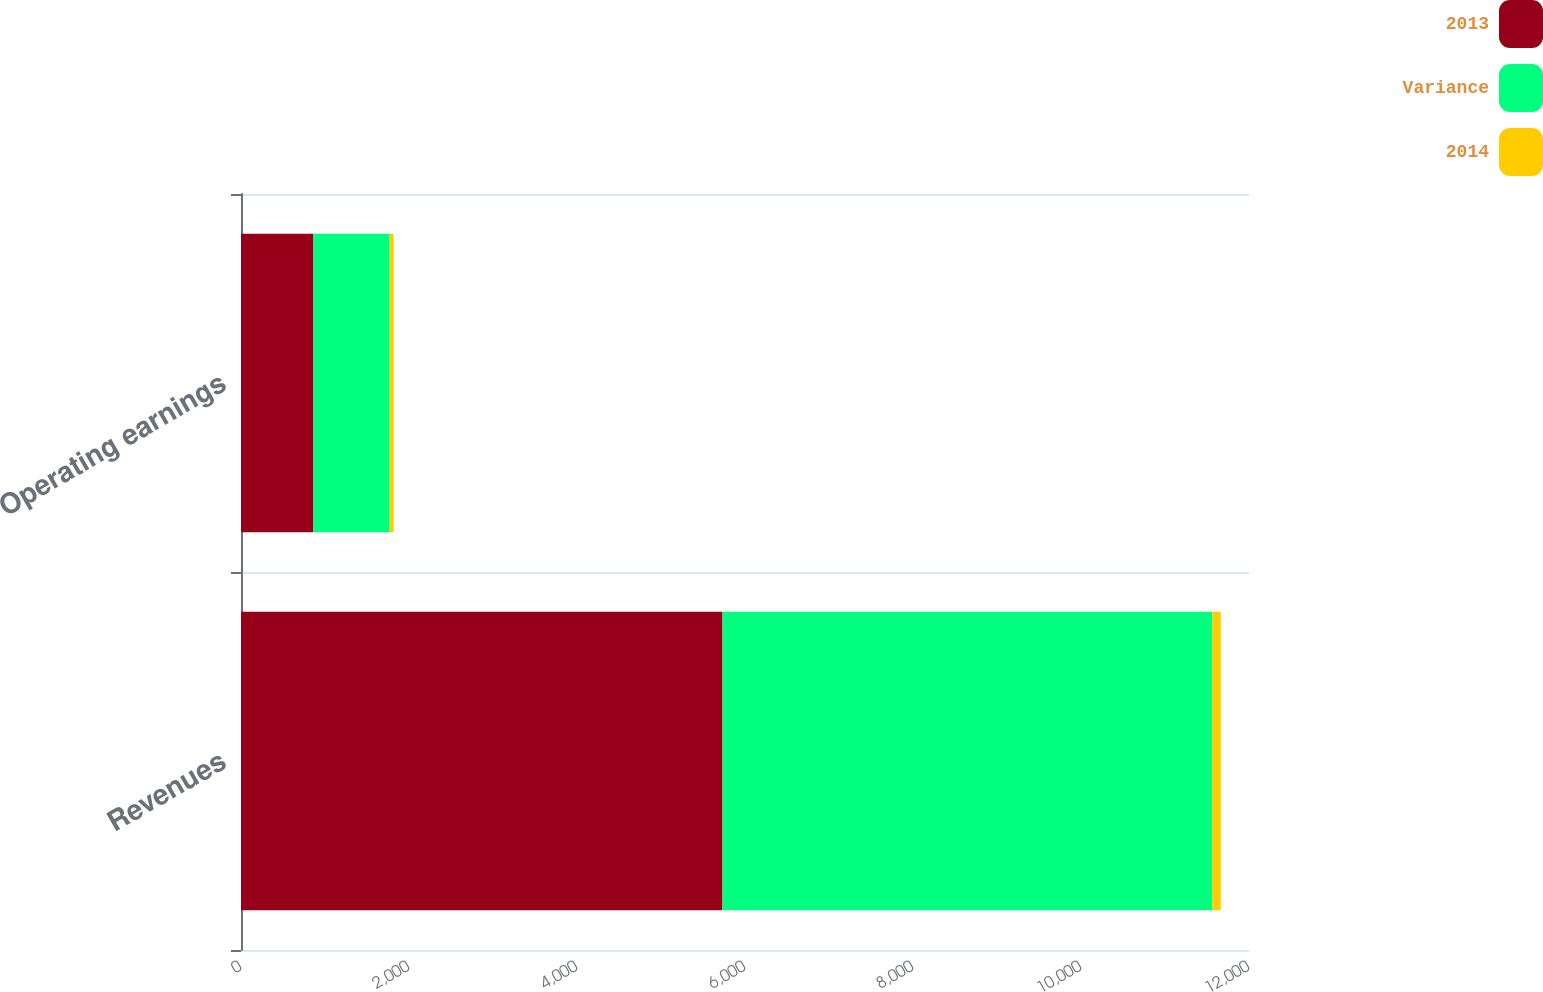Convert chart. <chart><loc_0><loc_0><loc_500><loc_500><stacked_bar_chart><ecel><fcel>Revenues<fcel>Operating earnings<nl><fcel>2013<fcel>5732<fcel>862<nl><fcel>Variance<fcel>5832<fcel>908<nl><fcel>2014<fcel>100<fcel>46<nl></chart> 